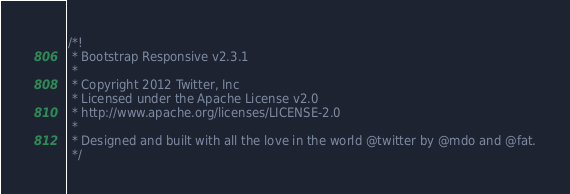Convert code to text. <code><loc_0><loc_0><loc_500><loc_500><_CSS_>/*!
 * Bootstrap Responsive v2.3.1
 *
 * Copyright 2012 Twitter, Inc
 * Licensed under the Apache License v2.0
 * http://www.apache.org/licenses/LICENSE-2.0
 *
 * Designed and built with all the love in the world @twitter by @mdo and @fat.
 */</code> 